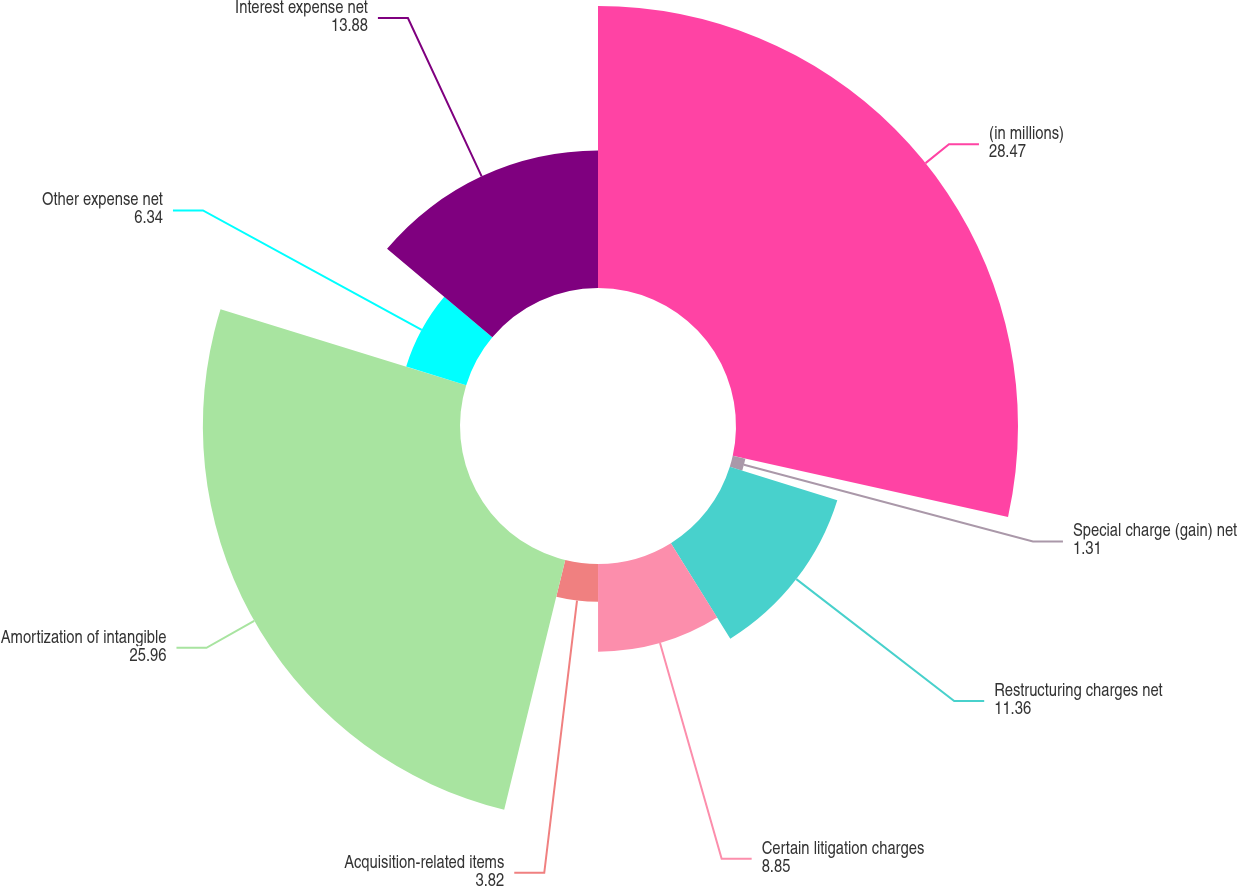Convert chart. <chart><loc_0><loc_0><loc_500><loc_500><pie_chart><fcel>(in millions)<fcel>Special charge (gain) net<fcel>Restructuring charges net<fcel>Certain litigation charges<fcel>Acquisition-related items<fcel>Amortization of intangible<fcel>Other expense net<fcel>Interest expense net<nl><fcel>28.47%<fcel>1.31%<fcel>11.36%<fcel>8.85%<fcel>3.82%<fcel>25.96%<fcel>6.34%<fcel>13.88%<nl></chart> 